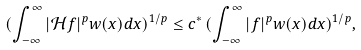<formula> <loc_0><loc_0><loc_500><loc_500>( \int _ { - \infty } ^ { \infty } | \mathcal { H } f | ^ { p } w ( x ) d x ) ^ { 1 / p } \leq c ^ { * } \, ( \int _ { - \infty } ^ { \infty } | f | ^ { p } w ( x ) d x ) ^ { 1 / p } ,</formula> 